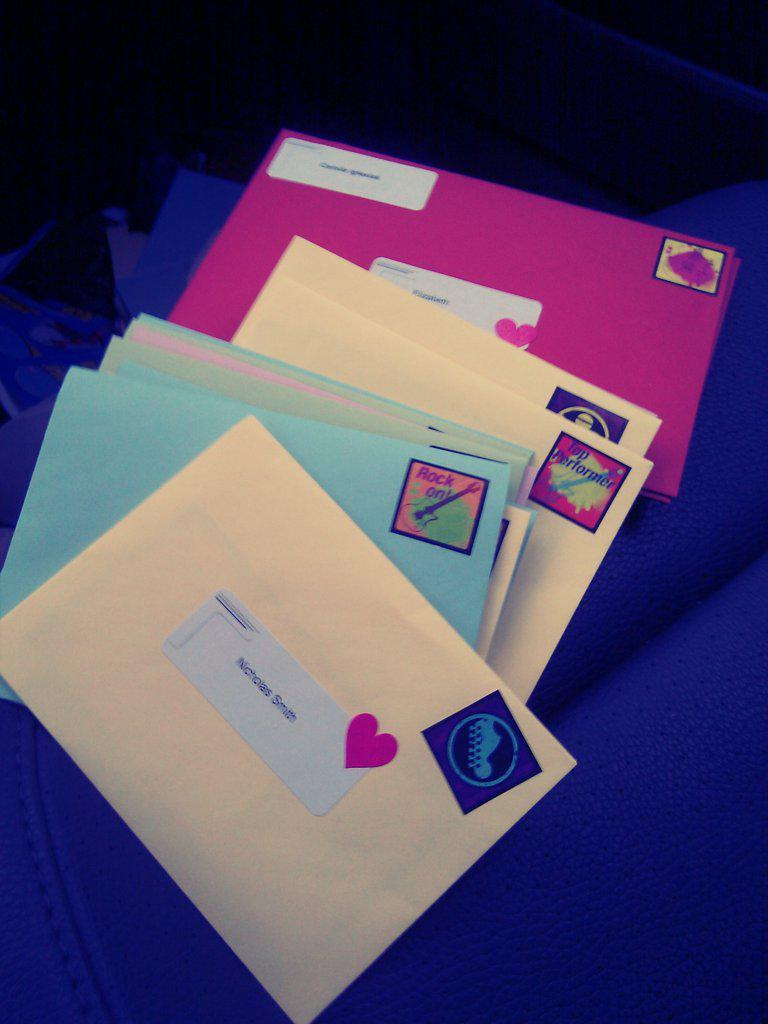<image>
Describe the image concisely. Several letters are stacked up, the top one being intended for Nicholas Smith. 